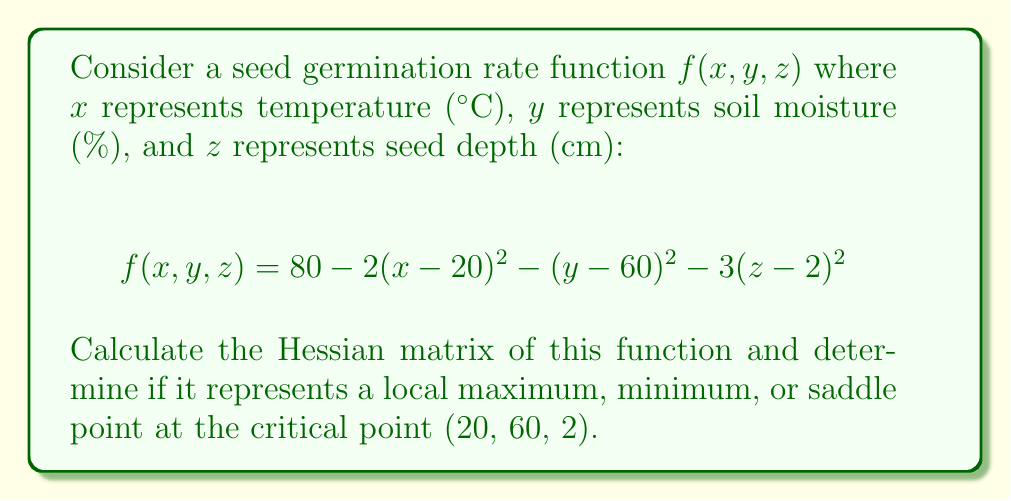Teach me how to tackle this problem. 1) First, let's calculate the second partial derivatives for the Hessian matrix:

   $\frac{\partial^2 f}{\partial x^2} = -4$
   $\frac{\partial^2 f}{\partial y^2} = -2$
   $\frac{\partial^2 f}{\partial z^2} = -6$
   $\frac{\partial^2 f}{\partial x\partial y} = \frac{\partial^2 f}{\partial y\partial x} = 0$
   $\frac{\partial^2 f}{\partial x\partial z} = \frac{\partial^2 f}{\partial z\partial x} = 0$
   $\frac{\partial^2 f}{\partial y\partial z} = \frac{\partial^2 f}{\partial z\partial y} = 0$

2) The Hessian matrix is:

   $$H = \begin{bmatrix} 
   -4 & 0 & 0 \\
   0 & -2 & 0 \\
   0 & 0 & -6
   \end{bmatrix}$$

3) To determine the nature of the critical point, we need to check the eigenvalues of the Hessian:
   
   The eigenvalues are the diagonal entries: $-4, -2, -6$

4) Since all eigenvalues are negative, the Hessian is negative definite.

5) For a negative definite Hessian, the critical point (20, 60, 2) is a local maximum.

6) The maximum germination rate at this point is:
   
   $f(20, 60, 2) = 80 - 2(20-20)^2 - (60-60)^2 - 3(2-2)^2 = 80$
Answer: The Hessian matrix is $\begin{bmatrix} -4 & 0 & 0 \\ 0 & -2 & 0 \\ 0 & 0 & -6 \end{bmatrix}$. The critical point (20, 60, 2) is a local maximum with a germination rate of 80%. 